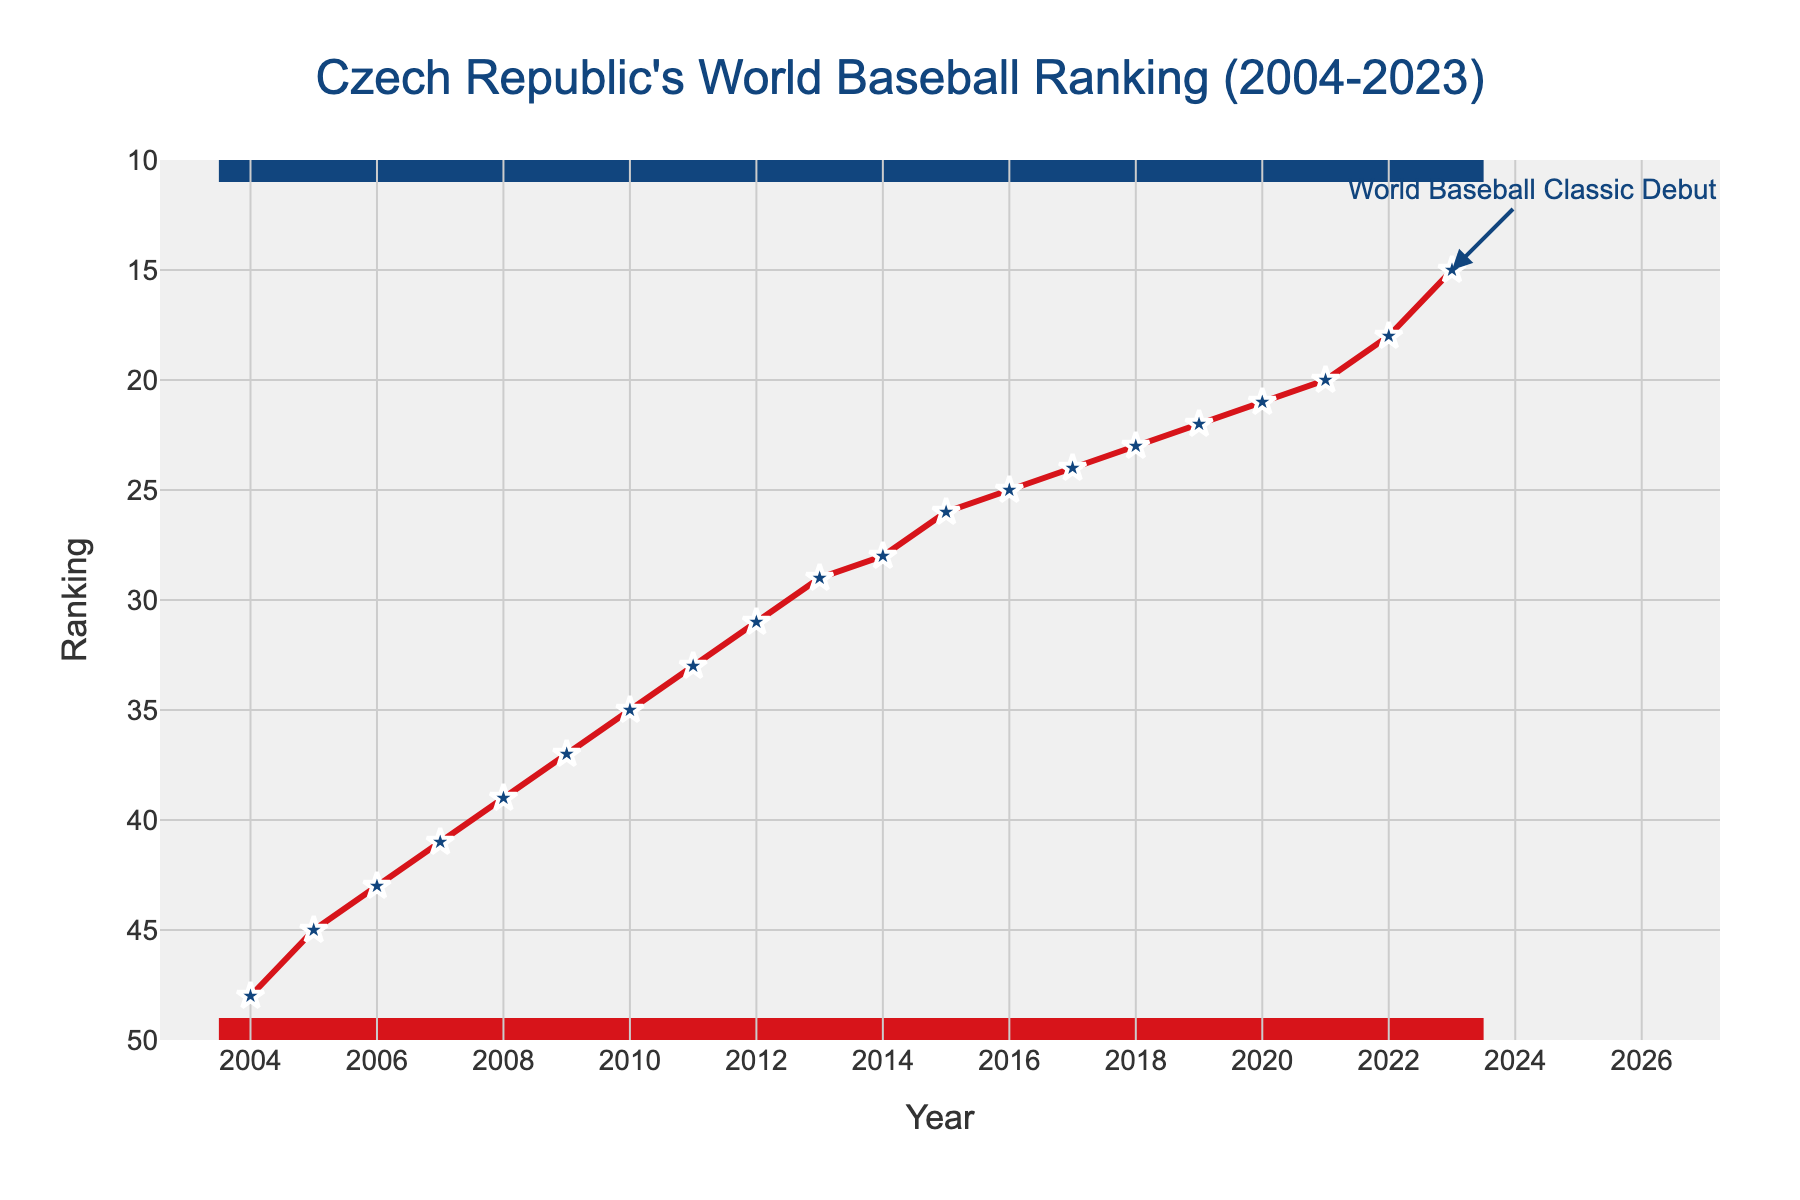What is the lowest ranking for the Czech Republic in the data? The lowest ranking value in the data appears to be around the start of the data series. From the plot, in 2004, the Czech Republic had its lowest ranking, which is shown as the highest point on the 'y' axis.
Answer: 48 Between which years did the Czech Republic's ranking improve the most? Looking at the largest vertical drop between two adjacent years, the greatest improvement is visible between 2022 and 2023, where the ranking dropped more sharply than any other interval.
Answer: 2022 and 2023 What is the average ranking from 2004 to 2023? To calculate the average ranking, add up all the rankings from 2004 to 2023 and divide by the number of years. (48+45+43+41+39+37+35+33+31+29+28+26+25+24+23+22+21+20+18+15)/20 = 31.2
Answer: 31.2 In which year did the Czech Republic enter the top 20 rankings? The plot shows the Czech Republic's ranking improving year by year. They entered the top 20 in 2021.
Answer: 2021 What is the color of the line representing the Czech Republic's ranking over the years? The line representing the Czech Republic's ranking is visually distinct by being red.
Answer: Red Which year is annotated and what does the annotation indicate? The year 2023 is annotated with the text "World Baseball Classic Debut" and an arrow pointing to the data point.
Answer: 2023 How much did the Czech Republic's ranking improve from 2010 to 2015? By observing the plot, the ranking in 2010 was 35, and in 2015 it was 26, indicating an improvement of 35 - 26 = 9 ranks.
Answer: 9 Compare the ranking change between 2015-2020 and 2020-2023. Which period had a greater change? From 2015 to 2020, the ranking changed from 26 to 21, a difference of 5 ranks. From 2020 to 2023, it changed from 21 to 15, a difference of 6 ranks. So, the period 2020-2023 had a greater change.
Answer: 2020-2023 Between 2009 and 2018, which year had the smallest improvement compared to the previous year? By examining each step between the years 2009 and 2018, the year 2010 to 2011 shows the smallest vertical drop (2 ranks), indicating the smallest improvement.
Answer: 2010 to 2011 